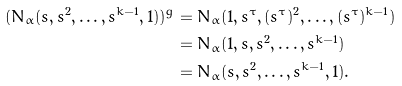<formula> <loc_0><loc_0><loc_500><loc_500>( N _ { \alpha } ( s , s ^ { 2 } , \dots , s ^ { k - 1 } , 1 ) ) ^ { g } & = N _ { \alpha } ( 1 , s ^ { \tau } , ( s ^ { \tau } ) ^ { 2 } , \dots , ( s ^ { \tau } ) ^ { k - 1 } ) \\ & = N _ { \alpha } ( 1 , s , s ^ { 2 } , \dots , s ^ { k - 1 } ) \\ & = N _ { \alpha } ( s , s ^ { 2 } , \dots , s ^ { k - 1 } , 1 ) .</formula> 